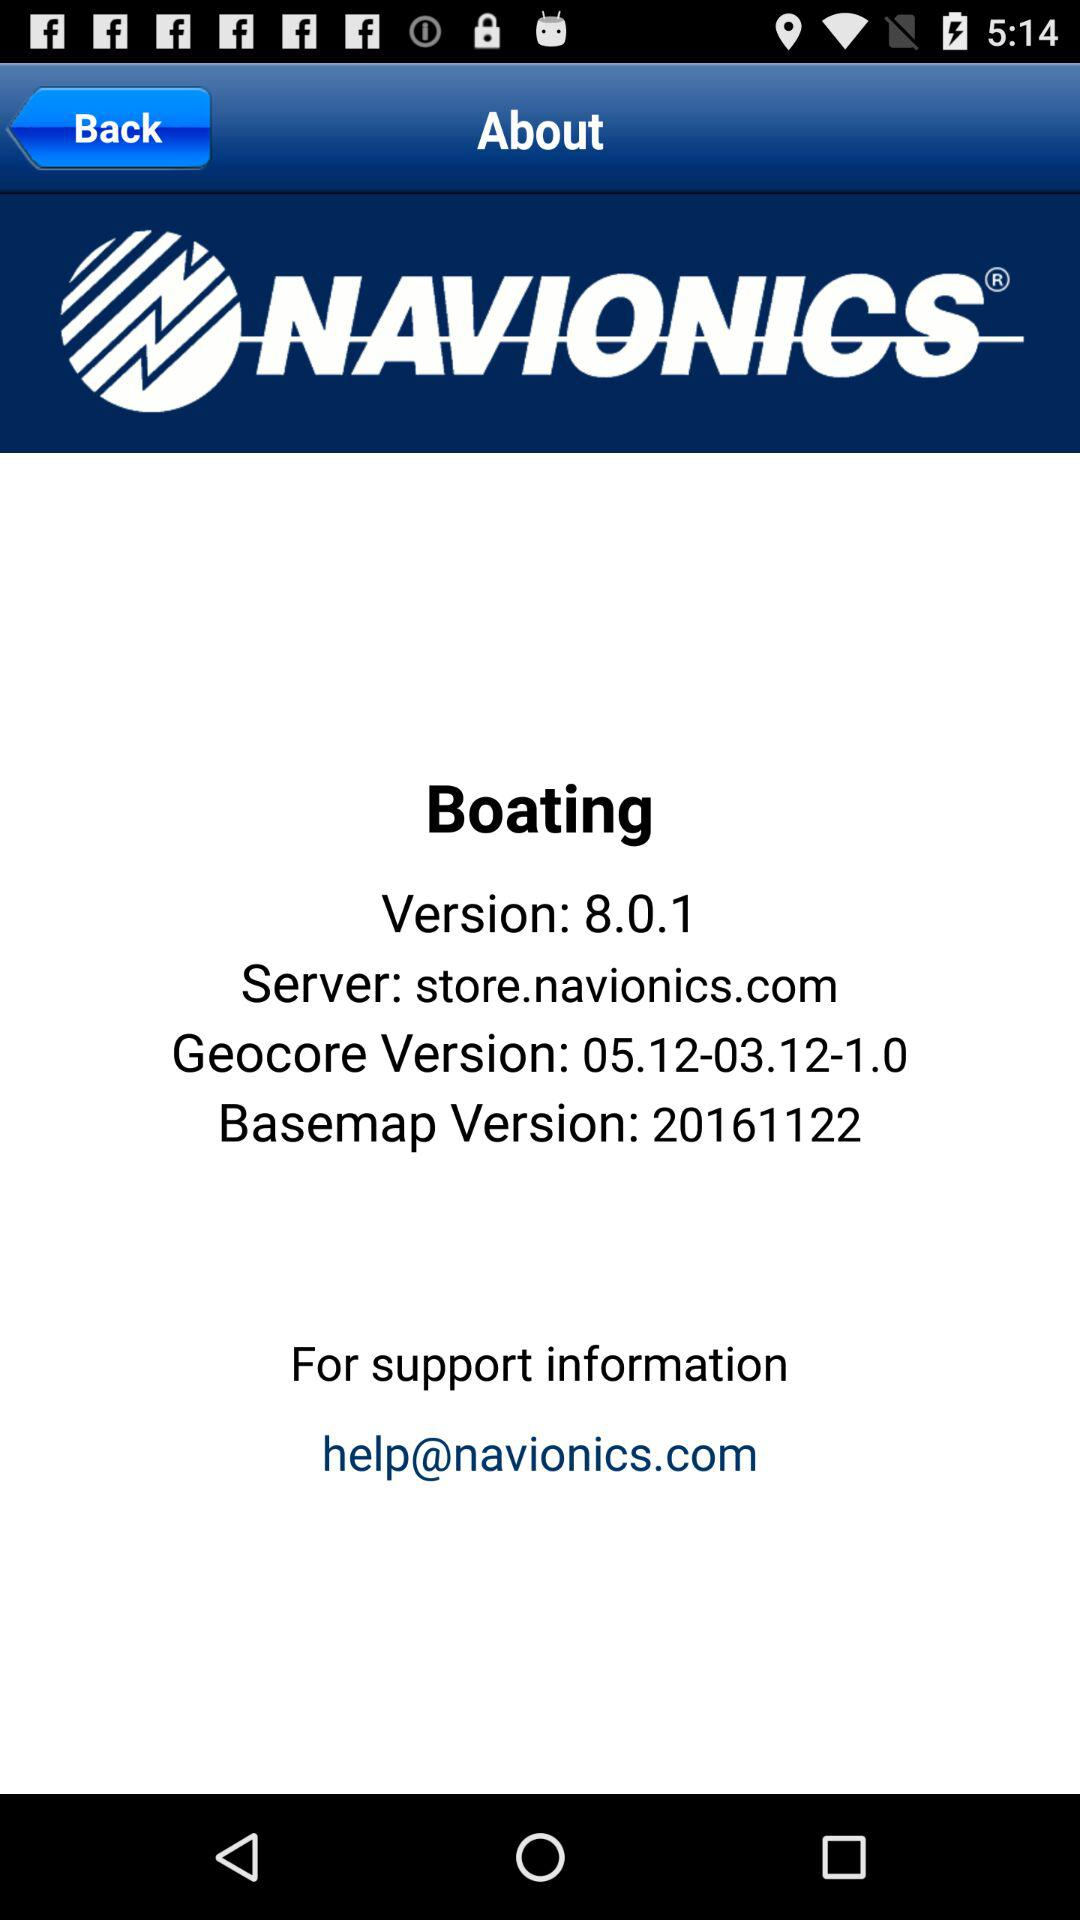What is the name of the application? The name of the application is "NAVIONICS®". 